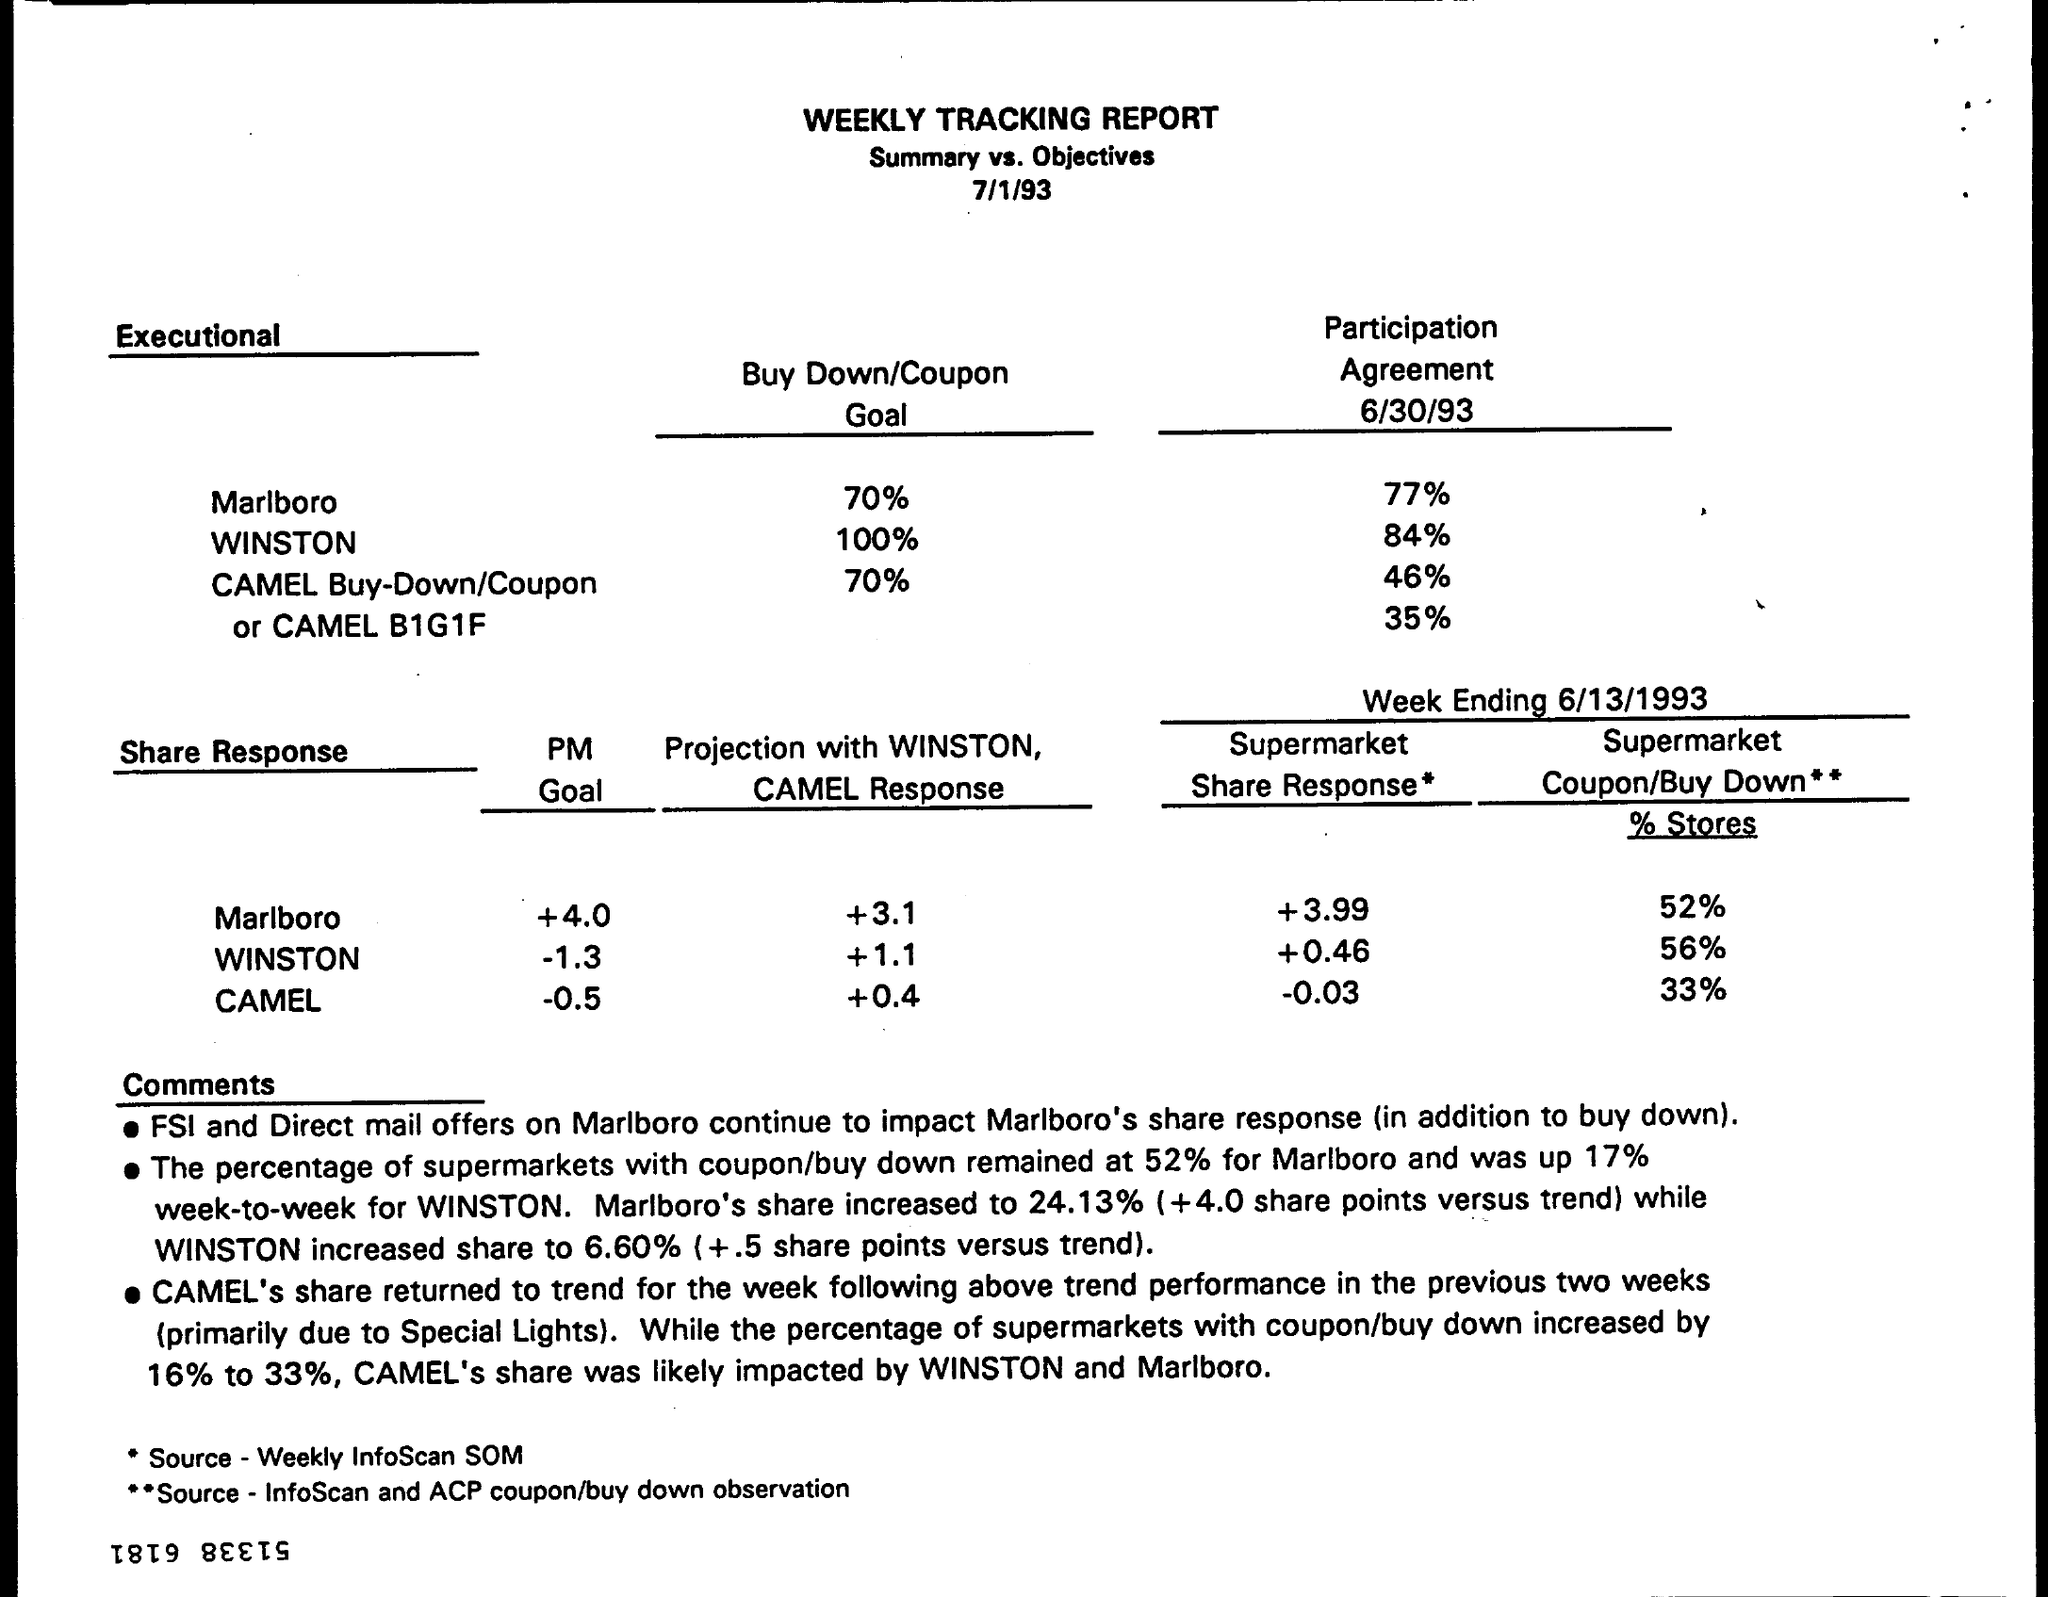What is the Title of the document?
Make the answer very short. WEEKLY TRACKING REPORT. What is the date on the document?
Offer a very short reply. 7/1/93. What is the Participant Agreement 6/30/93 for Marlboro?
Your answer should be very brief. 77%. What is the Participant Agreement 6/30/93 for Winston?
Offer a very short reply. 84%. What is the PM Goal for Marlboro?
Provide a succinct answer. +4.0. What is the PM Goal for Camel?
Provide a short and direct response. -0.5. What is the PM Goal for Winston?
Give a very brief answer. -1.3. What is the Buy Down/Coupon Goal for Marlboro?
Your answer should be very brief. 70%. What is the Buy Down/Coupon Goal for Winston?
Offer a terse response. 100%. What is the Buy Down/Coupon Goal for Camel?
Offer a very short reply. 70%. 